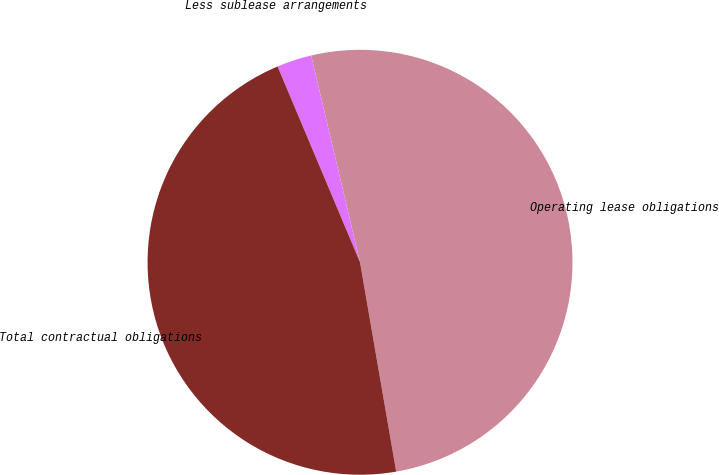Convert chart. <chart><loc_0><loc_0><loc_500><loc_500><pie_chart><fcel>Operating lease obligations<fcel>Less sublease arrangements<fcel>Total contractual obligations<nl><fcel>50.97%<fcel>2.65%<fcel>46.38%<nl></chart> 